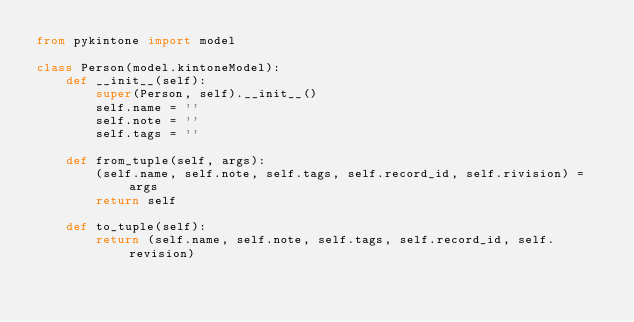<code> <loc_0><loc_0><loc_500><loc_500><_Python_>from pykintone import model

class Person(model.kintoneModel):
    def __init__(self):
        super(Person, self).__init__()
        self.name = ''
        self.note = ''
        self.tags = ''

    def from_tuple(self, args):
        (self.name, self.note, self.tags, self.record_id, self.rivision) = args
        return self

    def to_tuple(self):
        return (self.name, self.note, self.tags, self.record_id, self.revision)
</code> 